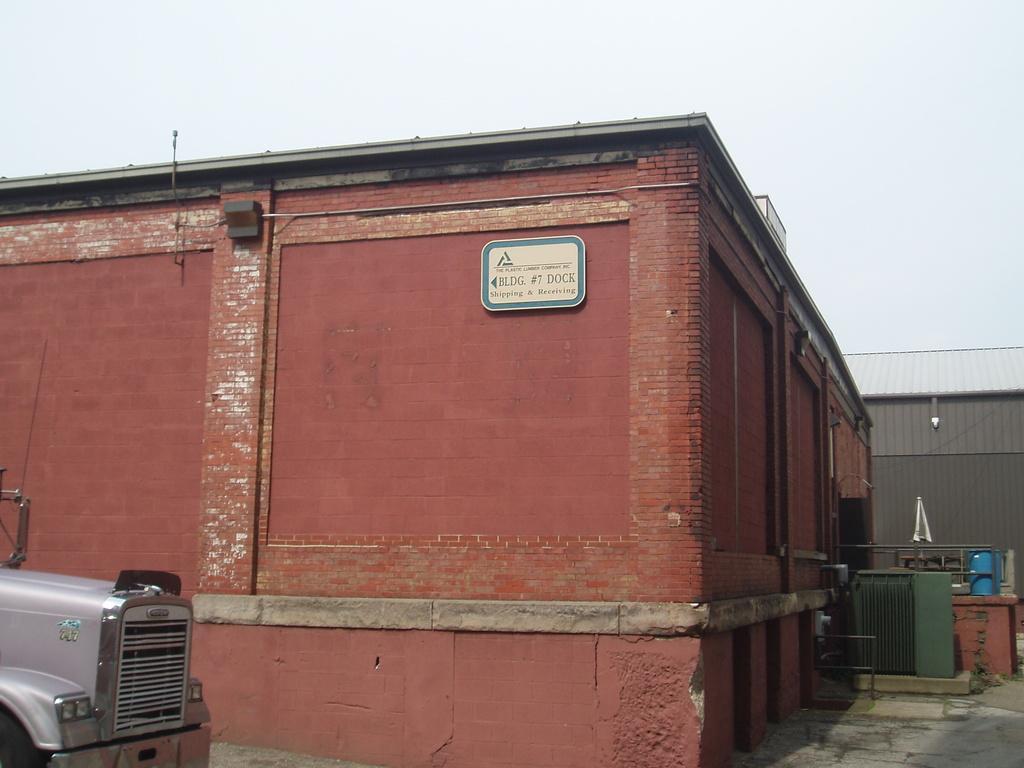Describe this image in one or two sentences. In this picture we can see two buildings, on the left side there is a vehicle, we can see a machine on the right side, there is a board pasted on the wall, we can see the sky at the top of the picture. 